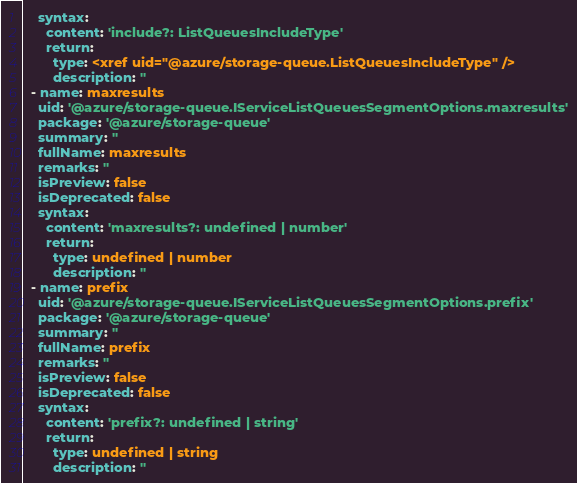<code> <loc_0><loc_0><loc_500><loc_500><_YAML_>    syntax:
      content: 'include?: ListQueuesIncludeType'
      return:
        type: <xref uid="@azure/storage-queue.ListQueuesIncludeType" />
        description: ''
  - name: maxresults
    uid: '@azure/storage-queue.IServiceListQueuesSegmentOptions.maxresults'
    package: '@azure/storage-queue'
    summary: ''
    fullName: maxresults
    remarks: ''
    isPreview: false
    isDeprecated: false
    syntax:
      content: 'maxresults?: undefined | number'
      return:
        type: undefined | number
        description: ''
  - name: prefix
    uid: '@azure/storage-queue.IServiceListQueuesSegmentOptions.prefix'
    package: '@azure/storage-queue'
    summary: ''
    fullName: prefix
    remarks: ''
    isPreview: false
    isDeprecated: false
    syntax:
      content: 'prefix?: undefined | string'
      return:
        type: undefined | string
        description: ''
</code> 